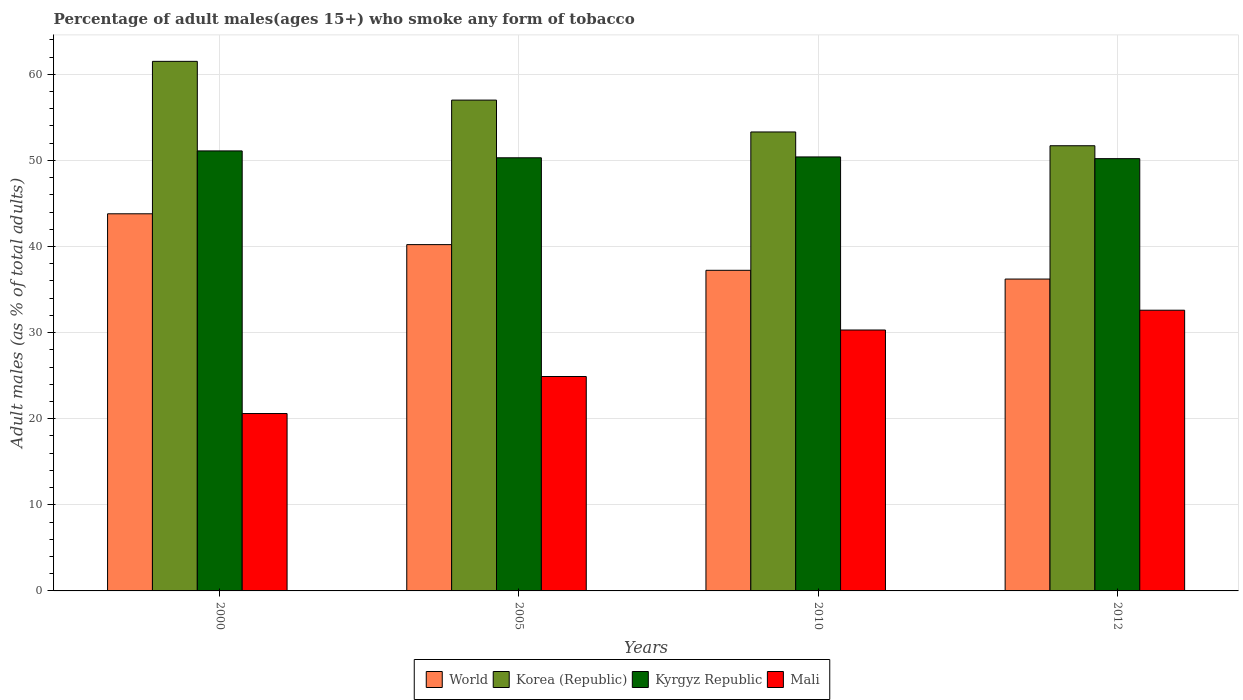How many different coloured bars are there?
Keep it short and to the point. 4. How many bars are there on the 4th tick from the right?
Offer a very short reply. 4. What is the label of the 1st group of bars from the left?
Make the answer very short. 2000. In how many cases, is the number of bars for a given year not equal to the number of legend labels?
Offer a terse response. 0. What is the percentage of adult males who smoke in World in 2010?
Offer a very short reply. 37.23. Across all years, what is the maximum percentage of adult males who smoke in World?
Your response must be concise. 43.8. Across all years, what is the minimum percentage of adult males who smoke in World?
Give a very brief answer. 36.22. In which year was the percentage of adult males who smoke in Korea (Republic) minimum?
Your answer should be very brief. 2012. What is the total percentage of adult males who smoke in Korea (Republic) in the graph?
Offer a very short reply. 223.5. What is the difference between the percentage of adult males who smoke in Korea (Republic) in 2010 and that in 2012?
Give a very brief answer. 1.6. What is the difference between the percentage of adult males who smoke in Mali in 2005 and the percentage of adult males who smoke in Korea (Republic) in 2012?
Your answer should be compact. -26.8. What is the average percentage of adult males who smoke in World per year?
Ensure brevity in your answer.  39.37. In the year 2000, what is the difference between the percentage of adult males who smoke in Mali and percentage of adult males who smoke in World?
Offer a very short reply. -23.2. What is the ratio of the percentage of adult males who smoke in Kyrgyz Republic in 2010 to that in 2012?
Keep it short and to the point. 1. Is the difference between the percentage of adult males who smoke in Mali in 2005 and 2012 greater than the difference between the percentage of adult males who smoke in World in 2005 and 2012?
Offer a terse response. No. What is the difference between the highest and the second highest percentage of adult males who smoke in Kyrgyz Republic?
Offer a terse response. 0.7. What is the difference between the highest and the lowest percentage of adult males who smoke in Korea (Republic)?
Your answer should be very brief. 9.8. In how many years, is the percentage of adult males who smoke in World greater than the average percentage of adult males who smoke in World taken over all years?
Ensure brevity in your answer.  2. Is the sum of the percentage of adult males who smoke in World in 2005 and 2012 greater than the maximum percentage of adult males who smoke in Mali across all years?
Offer a very short reply. Yes. What does the 2nd bar from the left in 2010 represents?
Keep it short and to the point. Korea (Republic). What does the 1st bar from the right in 2005 represents?
Your answer should be very brief. Mali. How many bars are there?
Your answer should be very brief. 16. Are all the bars in the graph horizontal?
Offer a very short reply. No. What is the difference between two consecutive major ticks on the Y-axis?
Your answer should be very brief. 10. Are the values on the major ticks of Y-axis written in scientific E-notation?
Offer a terse response. No. Does the graph contain any zero values?
Keep it short and to the point. No. Does the graph contain grids?
Provide a short and direct response. Yes. How are the legend labels stacked?
Your answer should be very brief. Horizontal. What is the title of the graph?
Make the answer very short. Percentage of adult males(ages 15+) who smoke any form of tobacco. What is the label or title of the Y-axis?
Make the answer very short. Adult males (as % of total adults). What is the Adult males (as % of total adults) in World in 2000?
Your answer should be compact. 43.8. What is the Adult males (as % of total adults) in Korea (Republic) in 2000?
Offer a terse response. 61.5. What is the Adult males (as % of total adults) in Kyrgyz Republic in 2000?
Provide a succinct answer. 51.1. What is the Adult males (as % of total adults) in Mali in 2000?
Provide a short and direct response. 20.6. What is the Adult males (as % of total adults) in World in 2005?
Your answer should be compact. 40.22. What is the Adult males (as % of total adults) in Korea (Republic) in 2005?
Provide a succinct answer. 57. What is the Adult males (as % of total adults) of Kyrgyz Republic in 2005?
Your response must be concise. 50.3. What is the Adult males (as % of total adults) in Mali in 2005?
Offer a very short reply. 24.9. What is the Adult males (as % of total adults) in World in 2010?
Ensure brevity in your answer.  37.23. What is the Adult males (as % of total adults) of Korea (Republic) in 2010?
Provide a succinct answer. 53.3. What is the Adult males (as % of total adults) in Kyrgyz Republic in 2010?
Provide a succinct answer. 50.4. What is the Adult males (as % of total adults) in Mali in 2010?
Make the answer very short. 30.3. What is the Adult males (as % of total adults) of World in 2012?
Your answer should be compact. 36.22. What is the Adult males (as % of total adults) of Korea (Republic) in 2012?
Provide a short and direct response. 51.7. What is the Adult males (as % of total adults) in Kyrgyz Republic in 2012?
Make the answer very short. 50.2. What is the Adult males (as % of total adults) of Mali in 2012?
Ensure brevity in your answer.  32.6. Across all years, what is the maximum Adult males (as % of total adults) of World?
Ensure brevity in your answer.  43.8. Across all years, what is the maximum Adult males (as % of total adults) in Korea (Republic)?
Offer a terse response. 61.5. Across all years, what is the maximum Adult males (as % of total adults) in Kyrgyz Republic?
Offer a terse response. 51.1. Across all years, what is the maximum Adult males (as % of total adults) of Mali?
Keep it short and to the point. 32.6. Across all years, what is the minimum Adult males (as % of total adults) of World?
Offer a very short reply. 36.22. Across all years, what is the minimum Adult males (as % of total adults) of Korea (Republic)?
Provide a succinct answer. 51.7. Across all years, what is the minimum Adult males (as % of total adults) of Kyrgyz Republic?
Offer a very short reply. 50.2. Across all years, what is the minimum Adult males (as % of total adults) in Mali?
Your answer should be very brief. 20.6. What is the total Adult males (as % of total adults) in World in the graph?
Your answer should be compact. 157.46. What is the total Adult males (as % of total adults) of Korea (Republic) in the graph?
Make the answer very short. 223.5. What is the total Adult males (as % of total adults) of Kyrgyz Republic in the graph?
Your answer should be compact. 202. What is the total Adult males (as % of total adults) of Mali in the graph?
Provide a short and direct response. 108.4. What is the difference between the Adult males (as % of total adults) of World in 2000 and that in 2005?
Keep it short and to the point. 3.58. What is the difference between the Adult males (as % of total adults) in Korea (Republic) in 2000 and that in 2005?
Provide a short and direct response. 4.5. What is the difference between the Adult males (as % of total adults) in Kyrgyz Republic in 2000 and that in 2005?
Keep it short and to the point. 0.8. What is the difference between the Adult males (as % of total adults) in Mali in 2000 and that in 2005?
Your answer should be compact. -4.3. What is the difference between the Adult males (as % of total adults) of World in 2000 and that in 2010?
Offer a terse response. 6.56. What is the difference between the Adult males (as % of total adults) in Kyrgyz Republic in 2000 and that in 2010?
Ensure brevity in your answer.  0.7. What is the difference between the Adult males (as % of total adults) in World in 2000 and that in 2012?
Offer a terse response. 7.58. What is the difference between the Adult males (as % of total adults) in Mali in 2000 and that in 2012?
Make the answer very short. -12. What is the difference between the Adult males (as % of total adults) in World in 2005 and that in 2010?
Ensure brevity in your answer.  2.98. What is the difference between the Adult males (as % of total adults) of Mali in 2005 and that in 2010?
Provide a succinct answer. -5.4. What is the difference between the Adult males (as % of total adults) of World in 2005 and that in 2012?
Keep it short and to the point. 4. What is the difference between the Adult males (as % of total adults) in Korea (Republic) in 2005 and that in 2012?
Provide a short and direct response. 5.3. What is the difference between the Adult males (as % of total adults) in World in 2010 and that in 2012?
Your answer should be compact. 1.02. What is the difference between the Adult males (as % of total adults) in Korea (Republic) in 2010 and that in 2012?
Give a very brief answer. 1.6. What is the difference between the Adult males (as % of total adults) in Mali in 2010 and that in 2012?
Keep it short and to the point. -2.3. What is the difference between the Adult males (as % of total adults) in World in 2000 and the Adult males (as % of total adults) in Korea (Republic) in 2005?
Provide a short and direct response. -13.2. What is the difference between the Adult males (as % of total adults) of World in 2000 and the Adult males (as % of total adults) of Kyrgyz Republic in 2005?
Offer a terse response. -6.5. What is the difference between the Adult males (as % of total adults) of World in 2000 and the Adult males (as % of total adults) of Mali in 2005?
Keep it short and to the point. 18.9. What is the difference between the Adult males (as % of total adults) in Korea (Republic) in 2000 and the Adult males (as % of total adults) in Mali in 2005?
Give a very brief answer. 36.6. What is the difference between the Adult males (as % of total adults) of Kyrgyz Republic in 2000 and the Adult males (as % of total adults) of Mali in 2005?
Ensure brevity in your answer.  26.2. What is the difference between the Adult males (as % of total adults) of World in 2000 and the Adult males (as % of total adults) of Korea (Republic) in 2010?
Your response must be concise. -9.5. What is the difference between the Adult males (as % of total adults) of World in 2000 and the Adult males (as % of total adults) of Kyrgyz Republic in 2010?
Keep it short and to the point. -6.6. What is the difference between the Adult males (as % of total adults) of World in 2000 and the Adult males (as % of total adults) of Mali in 2010?
Ensure brevity in your answer.  13.5. What is the difference between the Adult males (as % of total adults) of Korea (Republic) in 2000 and the Adult males (as % of total adults) of Kyrgyz Republic in 2010?
Your response must be concise. 11.1. What is the difference between the Adult males (as % of total adults) in Korea (Republic) in 2000 and the Adult males (as % of total adults) in Mali in 2010?
Your response must be concise. 31.2. What is the difference between the Adult males (as % of total adults) of Kyrgyz Republic in 2000 and the Adult males (as % of total adults) of Mali in 2010?
Your answer should be compact. 20.8. What is the difference between the Adult males (as % of total adults) of World in 2000 and the Adult males (as % of total adults) of Korea (Republic) in 2012?
Offer a terse response. -7.9. What is the difference between the Adult males (as % of total adults) of World in 2000 and the Adult males (as % of total adults) of Kyrgyz Republic in 2012?
Offer a very short reply. -6.4. What is the difference between the Adult males (as % of total adults) in World in 2000 and the Adult males (as % of total adults) in Mali in 2012?
Ensure brevity in your answer.  11.2. What is the difference between the Adult males (as % of total adults) of Korea (Republic) in 2000 and the Adult males (as % of total adults) of Kyrgyz Republic in 2012?
Provide a short and direct response. 11.3. What is the difference between the Adult males (as % of total adults) of Korea (Republic) in 2000 and the Adult males (as % of total adults) of Mali in 2012?
Your response must be concise. 28.9. What is the difference between the Adult males (as % of total adults) of World in 2005 and the Adult males (as % of total adults) of Korea (Republic) in 2010?
Keep it short and to the point. -13.08. What is the difference between the Adult males (as % of total adults) in World in 2005 and the Adult males (as % of total adults) in Kyrgyz Republic in 2010?
Ensure brevity in your answer.  -10.18. What is the difference between the Adult males (as % of total adults) in World in 2005 and the Adult males (as % of total adults) in Mali in 2010?
Provide a succinct answer. 9.92. What is the difference between the Adult males (as % of total adults) in Korea (Republic) in 2005 and the Adult males (as % of total adults) in Mali in 2010?
Provide a short and direct response. 26.7. What is the difference between the Adult males (as % of total adults) of World in 2005 and the Adult males (as % of total adults) of Korea (Republic) in 2012?
Ensure brevity in your answer.  -11.48. What is the difference between the Adult males (as % of total adults) in World in 2005 and the Adult males (as % of total adults) in Kyrgyz Republic in 2012?
Ensure brevity in your answer.  -9.98. What is the difference between the Adult males (as % of total adults) of World in 2005 and the Adult males (as % of total adults) of Mali in 2012?
Your answer should be compact. 7.62. What is the difference between the Adult males (as % of total adults) of Korea (Republic) in 2005 and the Adult males (as % of total adults) of Kyrgyz Republic in 2012?
Your answer should be compact. 6.8. What is the difference between the Adult males (as % of total adults) in Korea (Republic) in 2005 and the Adult males (as % of total adults) in Mali in 2012?
Give a very brief answer. 24.4. What is the difference between the Adult males (as % of total adults) in World in 2010 and the Adult males (as % of total adults) in Korea (Republic) in 2012?
Provide a short and direct response. -14.47. What is the difference between the Adult males (as % of total adults) in World in 2010 and the Adult males (as % of total adults) in Kyrgyz Republic in 2012?
Provide a succinct answer. -12.97. What is the difference between the Adult males (as % of total adults) in World in 2010 and the Adult males (as % of total adults) in Mali in 2012?
Provide a succinct answer. 4.63. What is the difference between the Adult males (as % of total adults) of Korea (Republic) in 2010 and the Adult males (as % of total adults) of Kyrgyz Republic in 2012?
Your answer should be very brief. 3.1. What is the difference between the Adult males (as % of total adults) in Korea (Republic) in 2010 and the Adult males (as % of total adults) in Mali in 2012?
Your response must be concise. 20.7. What is the difference between the Adult males (as % of total adults) of Kyrgyz Republic in 2010 and the Adult males (as % of total adults) of Mali in 2012?
Your answer should be compact. 17.8. What is the average Adult males (as % of total adults) in World per year?
Your answer should be compact. 39.37. What is the average Adult males (as % of total adults) of Korea (Republic) per year?
Keep it short and to the point. 55.88. What is the average Adult males (as % of total adults) in Kyrgyz Republic per year?
Provide a short and direct response. 50.5. What is the average Adult males (as % of total adults) of Mali per year?
Offer a terse response. 27.1. In the year 2000, what is the difference between the Adult males (as % of total adults) of World and Adult males (as % of total adults) of Korea (Republic)?
Your answer should be very brief. -17.7. In the year 2000, what is the difference between the Adult males (as % of total adults) of World and Adult males (as % of total adults) of Kyrgyz Republic?
Offer a very short reply. -7.3. In the year 2000, what is the difference between the Adult males (as % of total adults) in World and Adult males (as % of total adults) in Mali?
Ensure brevity in your answer.  23.2. In the year 2000, what is the difference between the Adult males (as % of total adults) in Korea (Republic) and Adult males (as % of total adults) in Mali?
Make the answer very short. 40.9. In the year 2000, what is the difference between the Adult males (as % of total adults) of Kyrgyz Republic and Adult males (as % of total adults) of Mali?
Give a very brief answer. 30.5. In the year 2005, what is the difference between the Adult males (as % of total adults) in World and Adult males (as % of total adults) in Korea (Republic)?
Offer a very short reply. -16.78. In the year 2005, what is the difference between the Adult males (as % of total adults) in World and Adult males (as % of total adults) in Kyrgyz Republic?
Offer a terse response. -10.08. In the year 2005, what is the difference between the Adult males (as % of total adults) in World and Adult males (as % of total adults) in Mali?
Provide a succinct answer. 15.32. In the year 2005, what is the difference between the Adult males (as % of total adults) in Korea (Republic) and Adult males (as % of total adults) in Mali?
Keep it short and to the point. 32.1. In the year 2005, what is the difference between the Adult males (as % of total adults) of Kyrgyz Republic and Adult males (as % of total adults) of Mali?
Your response must be concise. 25.4. In the year 2010, what is the difference between the Adult males (as % of total adults) in World and Adult males (as % of total adults) in Korea (Republic)?
Your response must be concise. -16.07. In the year 2010, what is the difference between the Adult males (as % of total adults) of World and Adult males (as % of total adults) of Kyrgyz Republic?
Your answer should be compact. -13.17. In the year 2010, what is the difference between the Adult males (as % of total adults) in World and Adult males (as % of total adults) in Mali?
Your answer should be compact. 6.93. In the year 2010, what is the difference between the Adult males (as % of total adults) of Korea (Republic) and Adult males (as % of total adults) of Mali?
Offer a very short reply. 23. In the year 2010, what is the difference between the Adult males (as % of total adults) of Kyrgyz Republic and Adult males (as % of total adults) of Mali?
Your response must be concise. 20.1. In the year 2012, what is the difference between the Adult males (as % of total adults) in World and Adult males (as % of total adults) in Korea (Republic)?
Keep it short and to the point. -15.48. In the year 2012, what is the difference between the Adult males (as % of total adults) in World and Adult males (as % of total adults) in Kyrgyz Republic?
Provide a succinct answer. -13.98. In the year 2012, what is the difference between the Adult males (as % of total adults) in World and Adult males (as % of total adults) in Mali?
Make the answer very short. 3.62. In the year 2012, what is the difference between the Adult males (as % of total adults) of Kyrgyz Republic and Adult males (as % of total adults) of Mali?
Provide a short and direct response. 17.6. What is the ratio of the Adult males (as % of total adults) of World in 2000 to that in 2005?
Give a very brief answer. 1.09. What is the ratio of the Adult males (as % of total adults) in Korea (Republic) in 2000 to that in 2005?
Make the answer very short. 1.08. What is the ratio of the Adult males (as % of total adults) in Kyrgyz Republic in 2000 to that in 2005?
Your response must be concise. 1.02. What is the ratio of the Adult males (as % of total adults) in Mali in 2000 to that in 2005?
Your answer should be compact. 0.83. What is the ratio of the Adult males (as % of total adults) in World in 2000 to that in 2010?
Offer a terse response. 1.18. What is the ratio of the Adult males (as % of total adults) in Korea (Republic) in 2000 to that in 2010?
Your answer should be compact. 1.15. What is the ratio of the Adult males (as % of total adults) in Kyrgyz Republic in 2000 to that in 2010?
Provide a succinct answer. 1.01. What is the ratio of the Adult males (as % of total adults) of Mali in 2000 to that in 2010?
Provide a succinct answer. 0.68. What is the ratio of the Adult males (as % of total adults) of World in 2000 to that in 2012?
Provide a succinct answer. 1.21. What is the ratio of the Adult males (as % of total adults) in Korea (Republic) in 2000 to that in 2012?
Provide a succinct answer. 1.19. What is the ratio of the Adult males (as % of total adults) of Kyrgyz Republic in 2000 to that in 2012?
Offer a very short reply. 1.02. What is the ratio of the Adult males (as % of total adults) in Mali in 2000 to that in 2012?
Make the answer very short. 0.63. What is the ratio of the Adult males (as % of total adults) of World in 2005 to that in 2010?
Provide a short and direct response. 1.08. What is the ratio of the Adult males (as % of total adults) of Korea (Republic) in 2005 to that in 2010?
Ensure brevity in your answer.  1.07. What is the ratio of the Adult males (as % of total adults) of Kyrgyz Republic in 2005 to that in 2010?
Give a very brief answer. 1. What is the ratio of the Adult males (as % of total adults) in Mali in 2005 to that in 2010?
Provide a succinct answer. 0.82. What is the ratio of the Adult males (as % of total adults) in World in 2005 to that in 2012?
Offer a terse response. 1.11. What is the ratio of the Adult males (as % of total adults) in Korea (Republic) in 2005 to that in 2012?
Make the answer very short. 1.1. What is the ratio of the Adult males (as % of total adults) in Mali in 2005 to that in 2012?
Give a very brief answer. 0.76. What is the ratio of the Adult males (as % of total adults) in World in 2010 to that in 2012?
Your answer should be very brief. 1.03. What is the ratio of the Adult males (as % of total adults) in Korea (Republic) in 2010 to that in 2012?
Your answer should be compact. 1.03. What is the ratio of the Adult males (as % of total adults) of Kyrgyz Republic in 2010 to that in 2012?
Offer a terse response. 1. What is the ratio of the Adult males (as % of total adults) in Mali in 2010 to that in 2012?
Keep it short and to the point. 0.93. What is the difference between the highest and the second highest Adult males (as % of total adults) in World?
Keep it short and to the point. 3.58. What is the difference between the highest and the second highest Adult males (as % of total adults) of Korea (Republic)?
Your answer should be compact. 4.5. What is the difference between the highest and the lowest Adult males (as % of total adults) in World?
Ensure brevity in your answer.  7.58. What is the difference between the highest and the lowest Adult males (as % of total adults) in Korea (Republic)?
Offer a very short reply. 9.8. What is the difference between the highest and the lowest Adult males (as % of total adults) of Kyrgyz Republic?
Provide a succinct answer. 0.9. 